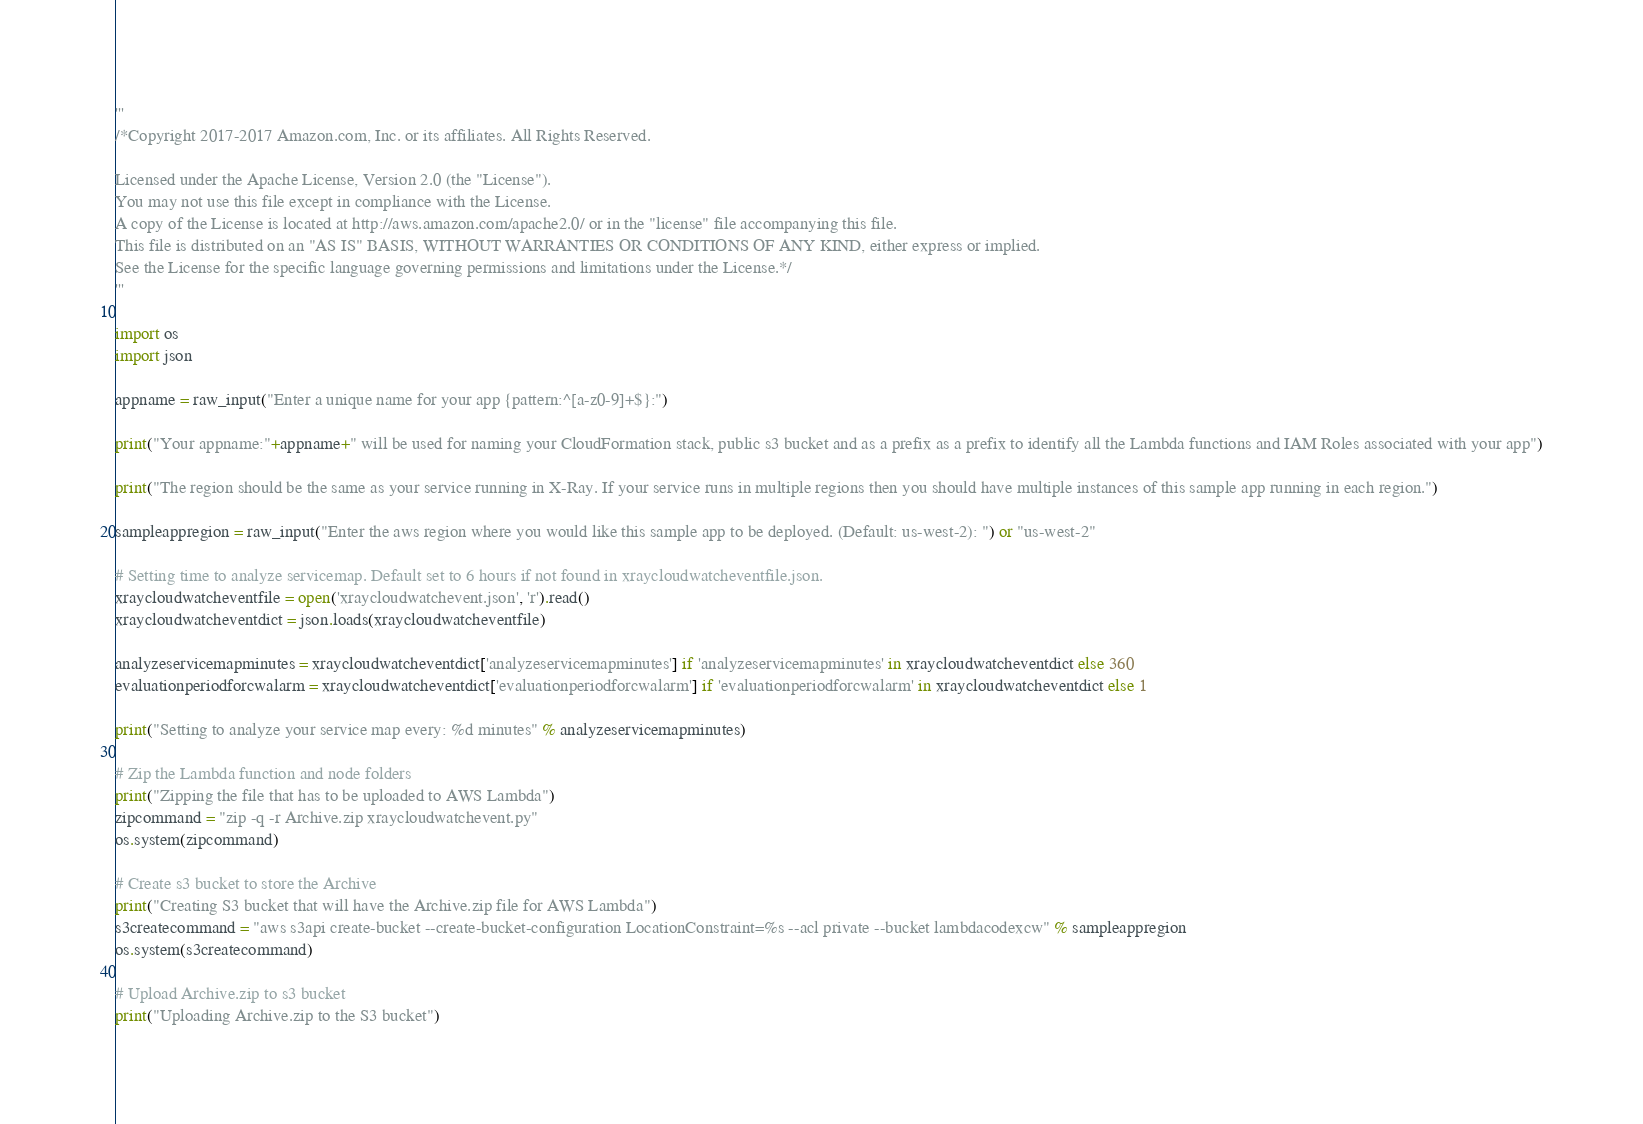<code> <loc_0><loc_0><loc_500><loc_500><_Python_>'''
/*Copyright 2017-2017 Amazon.com, Inc. or its affiliates. All Rights Reserved.

Licensed under the Apache License, Version 2.0 (the "License").
You may not use this file except in compliance with the License.
A copy of the License is located at http://aws.amazon.com/apache2.0/ or in the "license" file accompanying this file.
This file is distributed on an "AS IS" BASIS, WITHOUT WARRANTIES OR CONDITIONS OF ANY KIND, either express or implied.
See the License for the specific language governing permissions and limitations under the License.*/
'''

import os
import json

appname = raw_input("Enter a unique name for your app {pattern:^[a-z0-9]+$}:")

print("Your appname:"+appname+" will be used for naming your CloudFormation stack, public s3 bucket and as a prefix as a prefix to identify all the Lambda functions and IAM Roles associated with your app")

print("The region should be the same as your service running in X-Ray. If your service runs in multiple regions then you should have multiple instances of this sample app running in each region.")

sampleappregion = raw_input("Enter the aws region where you would like this sample app to be deployed. (Default: us-west-2): ") or "us-west-2"

# Setting time to analyze servicemap. Default set to 6 hours if not found in xraycloudwatcheventfile.json.
xraycloudwatcheventfile = open('xraycloudwatchevent.json', 'r').read()
xraycloudwatcheventdict = json.loads(xraycloudwatcheventfile)

analyzeservicemapminutes = xraycloudwatcheventdict['analyzeservicemapminutes'] if 'analyzeservicemapminutes' in xraycloudwatcheventdict else 360
evaluationperiodforcwalarm = xraycloudwatcheventdict['evaluationperiodforcwalarm'] if 'evaluationperiodforcwalarm' in xraycloudwatcheventdict else 1

print("Setting to analyze your service map every: %d minutes" % analyzeservicemapminutes)

# Zip the Lambda function and node folders
print("Zipping the file that has to be uploaded to AWS Lambda")
zipcommand = "zip -q -r Archive.zip xraycloudwatchevent.py"
os.system(zipcommand)

# Create s3 bucket to store the Archive
print("Creating S3 bucket that will have the Archive.zip file for AWS Lambda")
s3createcommand = "aws s3api create-bucket --create-bucket-configuration LocationConstraint=%s --acl private --bucket lambdacodexcw" % sampleappregion
os.system(s3createcommand)

# Upload Archive.zip to s3 bucket
print("Uploading Archive.zip to the S3 bucket")</code> 